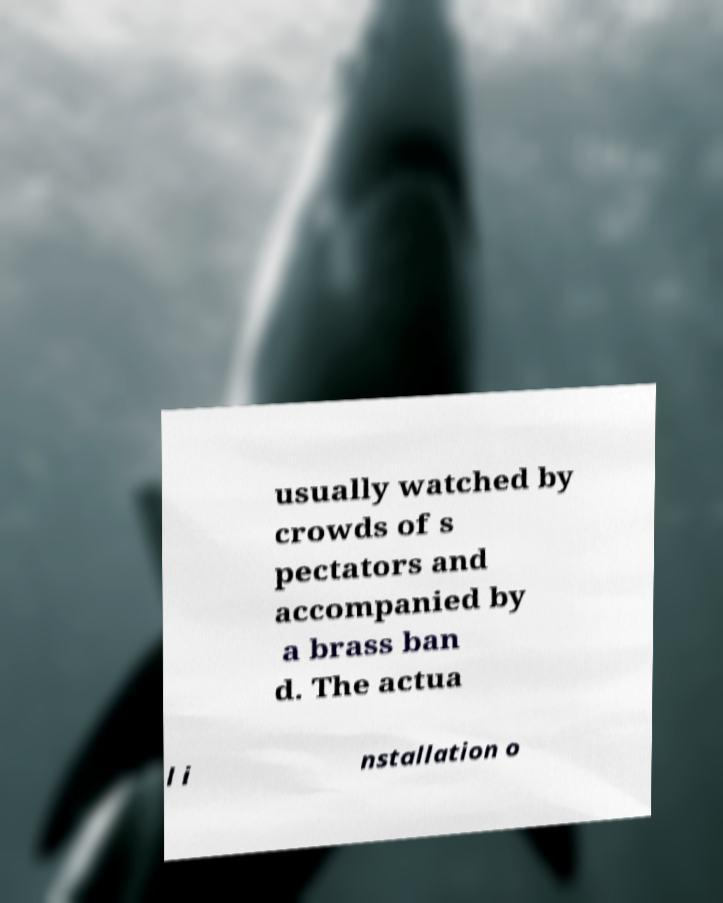Can you read and provide the text displayed in the image?This photo seems to have some interesting text. Can you extract and type it out for me? usually watched by crowds of s pectators and accompanied by a brass ban d. The actua l i nstallation o 